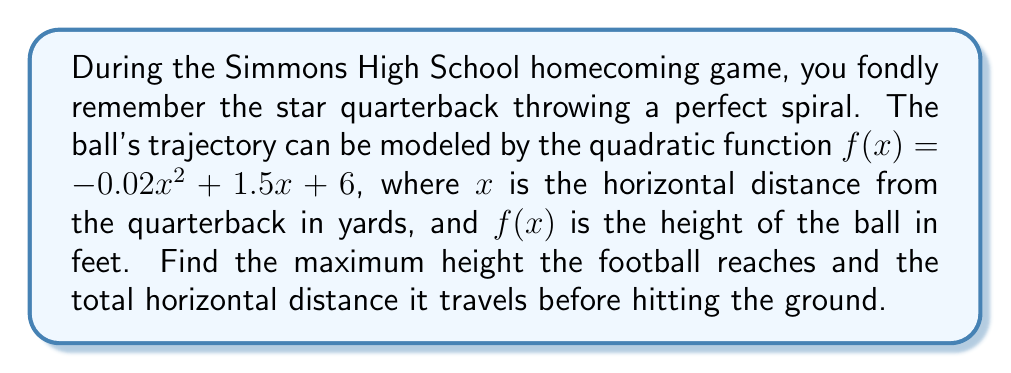What is the answer to this math problem? Let's approach this step-by-step:

1) The quadratic function is in the form $f(x) = ax^2 + bx + c$, where:
   $a = -0.02$, $b = 1.5$, and $c = 6$

2) To find the maximum height, we need to find the vertex of the parabola. The x-coordinate of the vertex is given by $x = -\frac{b}{2a}$:

   $x = -\frac{1.5}{2(-0.02)} = \frac{1.5}{0.04} = 37.5$ yards

3) To find the maximum height (y-coordinate of the vertex), we substitute this x-value into the original function:

   $f(37.5) = -0.02(37.5)^2 + 1.5(37.5) + 6$
   $= -0.02(1406.25) + 56.25 + 6$
   $= -28.125 + 56.25 + 6$
   $= 34.125$ feet

4) To find the total horizontal distance, we need to find where the ball hits the ground, which is where $f(x) = 0$:

   $0 = -0.02x^2 + 1.5x + 6$

5) We can solve this using the quadratic formula: $x = \frac{-b \pm \sqrt{b^2 - 4ac}}{2a}$

   $x = \frac{-1.5 \pm \sqrt{1.5^2 - 4(-0.02)(6)}}{2(-0.02)}$
   $= \frac{-1.5 \pm \sqrt{2.25 + 0.48}}{-0.04}$
   $= \frac{-1.5 \pm \sqrt{2.73}}{-0.04}$
   $= \frac{-1.5 \pm 1.65}{-0.04}$

6) This gives us two solutions:
   $x_1 = \frac{-1.5 + 1.65}{-0.04} = -3.75$ (we can discard this negative solution)
   $x_2 = \frac{-1.5 - 1.65}{-0.04} = 78.75$

Therefore, the ball travels 78.75 yards horizontally before hitting the ground.
Answer: The maximum height the football reaches is 34.125 feet, and it travels a total horizontal distance of 78.75 yards before hitting the ground. 